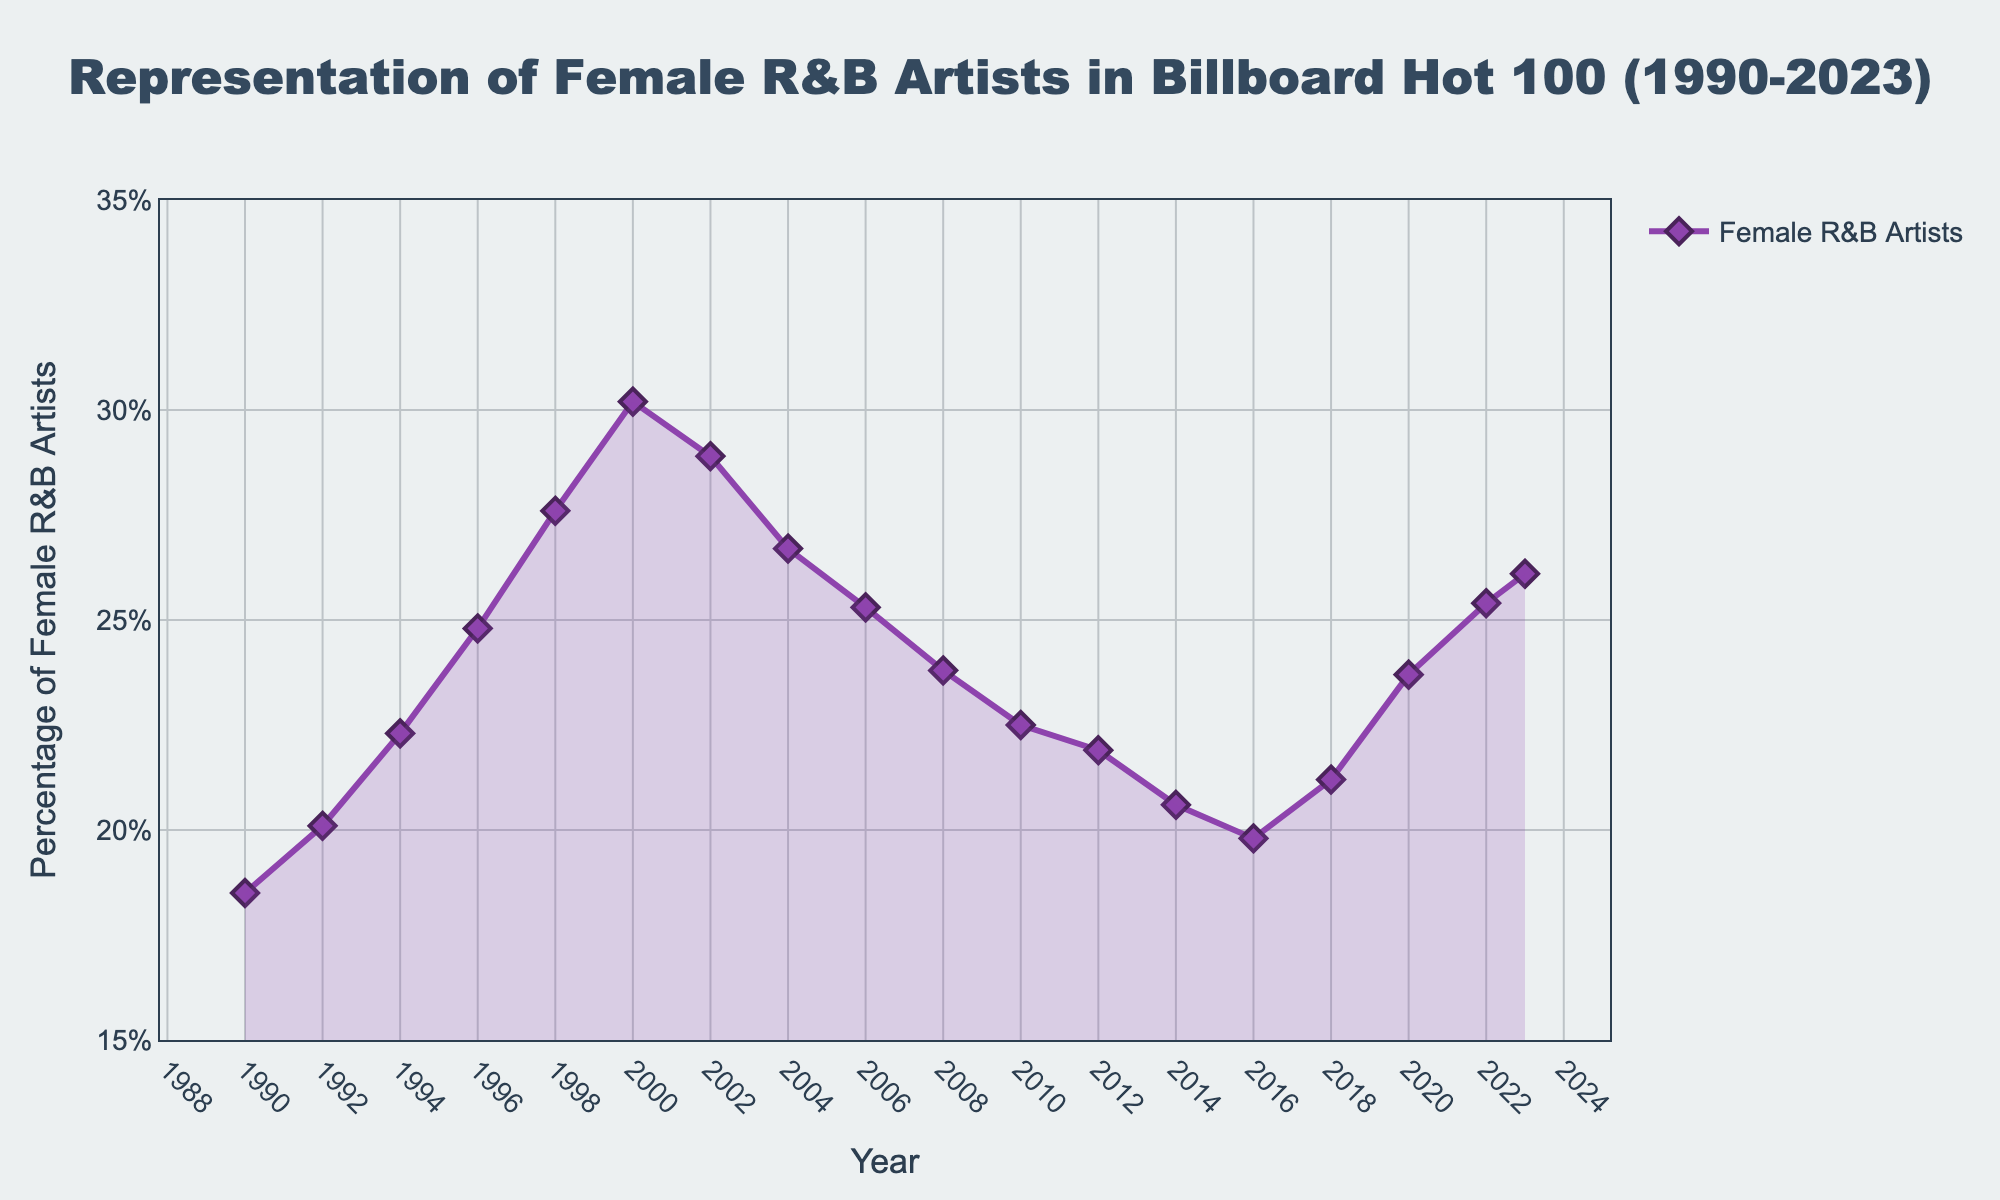What is the highest percentage of female R&B artists in the Billboard Hot 100 during the given period? The highest percentage can be found by identifying the maximum value in the dataset. The highest value observed is in the year 2000 at 30.2%.
Answer: 30.2% Which year had the lowest representation of female R&B artists in the Billboard Hot 100? To find the year with the lowest representation, look at the dataset for the minimum percentage value. The lowest value of 18.5% occurred in 1990.
Answer: 1990 What is the overall trend in the representation of female R&B artists from 1990 to 2023? Has it increased, decreased, or remained stable? Observing the plot, there is an overall increasing trend from 1990 to 2000, followed by a decrease until 2016, then some fluctuations, but generally, it has seen some recovery towards 2023. Therefore, there has been more fluctuation but a general trend of recovery towards the end.
Answer: Fluctuated with recovery What is the average percentage of female R&B artists in the Billboard Hot 100 over the entire period? Adding up all the percentage values and dividing by the number of years (17) gives the average. The sum of all values is 371.5: \( \text{Average} = \frac{371.5}{17} \approx 21.86\% \).
Answer: 21.86% How much did the representation of female R&B artists change from 1990 to 2000? The percentage in 1990 was 18.5%, and in 2000 it was 30.2%. The change is calculated by subtracting the earlier value from the later value: \(30.2 - 18.5 = 11.7\%\).
Answer: 11.7% In which year did the representation of female R&B artists peak, and what was the percentage? The peak percentage value can be pinpointed by looking for the highest value, which was in the year 2000 at 30.2%.
Answer: 2000, 30.2% Compare the representation of female R&B artists in 1998 and 2012. Which year had a higher percentage, and what is the difference between them? The percentage in 1998 was 27.6%, and in 2012 it was 21.9%. 1998 had a higher percentage. The difference is calculated by subtracting the lesser value from the greater value: \(27.6 - 21.9 = 5.7\%\).
Answer: 1998, 5.7% What is the percentage increase in the representation of female R&B artists from 2016 to 2023? Calculate the difference between the two years: 26.1% in 2023 and 19.8% in 2016. The increase is \(26.1 - 19.8 = 6.3\%\).
Answer: 6.3% During which periods did the representation of female R&B artists in the Billboard Hot 100 decrease? By analyzing the plot, identifying periods where the value goes down: from 2000 to 2008, from 2008 to 2016, and slightly from 1998 to 2002 and from 2020 to 2022.
Answer: 2000-2008, 2008-2016, 1998-2002, 2020-2022 Is there a noticeable pattern in the representation of female R&B artists between 1990 and 2022? If yes, describe it. Observing the fluctuations on the plot shows an initial increase until 2000, followed by a general decrease until around 2016, and then some recovery towards 2023 with irregular fluctuations. The pattern shows an increase followed by a decrease, and then another increase.
Answer: Increase, Decrease, Increase 